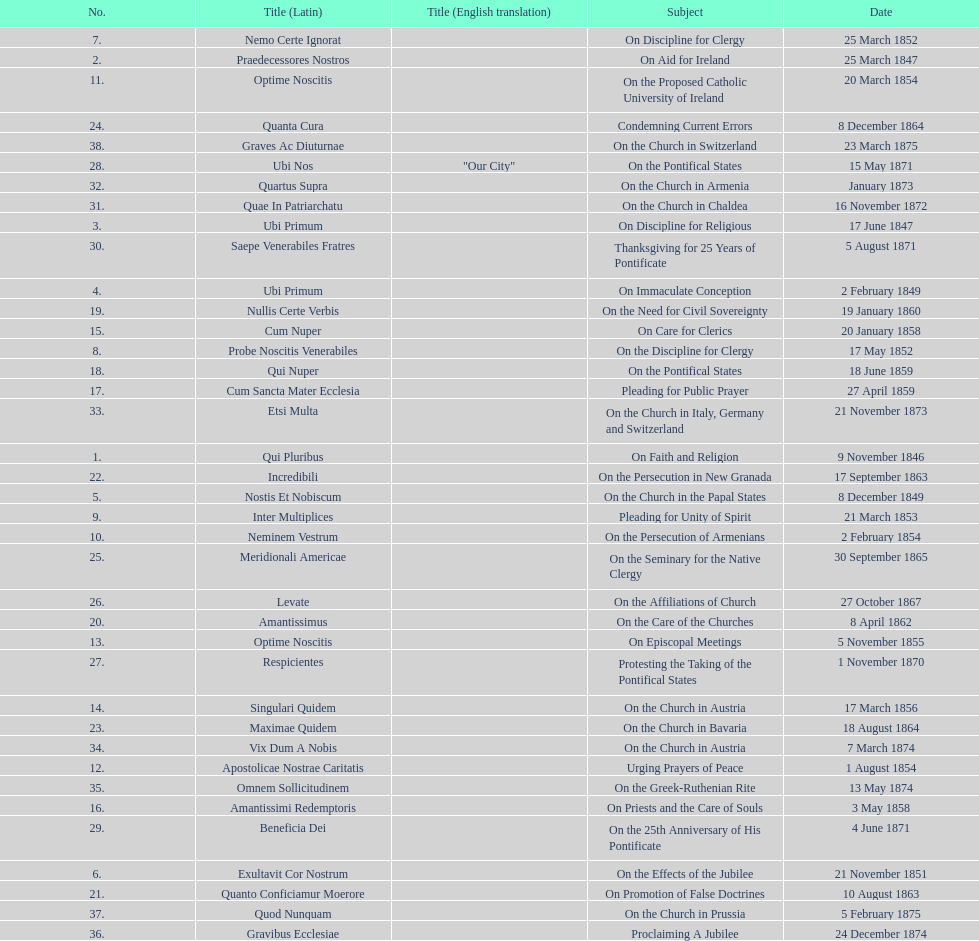Date of the last encyclical whose subject contained the word "pontificate" 5 August 1871. 